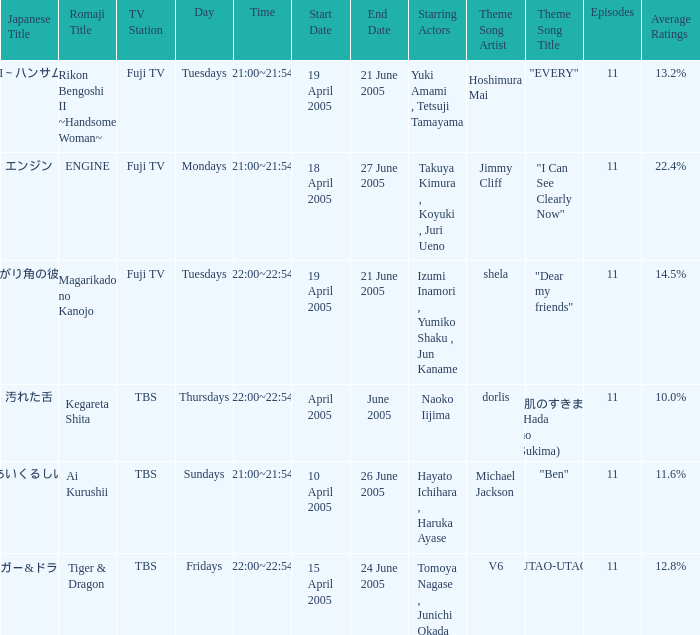What is maximum number of episodes for a show? 11.0. 